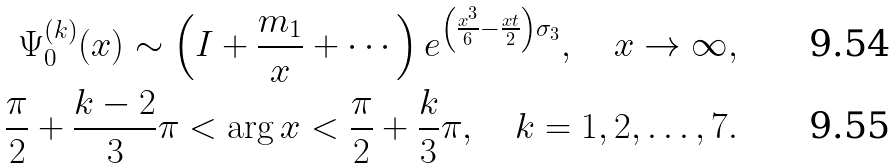Convert formula to latex. <formula><loc_0><loc_0><loc_500><loc_500>\Psi ^ { ( k ) } _ { 0 } ( x ) \sim \left ( I + \frac { m _ { 1 } } { x } + \cdots \right ) e ^ { \left ( \frac { x ^ { 3 } } { 6 } - \frac { x t } { 2 } \right ) \sigma _ { 3 } } , \quad x \to \infty , \\ \frac { \pi } { 2 } + \frac { k - 2 } { 3 } \pi < \arg x < \frac { \pi } { 2 } + \frac { k } { 3 } \pi , \quad k = 1 , 2 , \dots , 7 .</formula> 